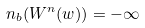<formula> <loc_0><loc_0><loc_500><loc_500>n _ { b } ( W ^ { n } ( w ) ) = - \infty</formula> 